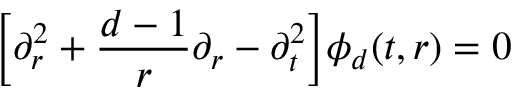<formula> <loc_0><loc_0><loc_500><loc_500>\left [ \partial _ { r } ^ { 2 } + \frac { d - 1 } { r } \partial _ { r } - \partial _ { t } ^ { 2 } \right ] \phi _ { d } ( t , r ) = 0</formula> 